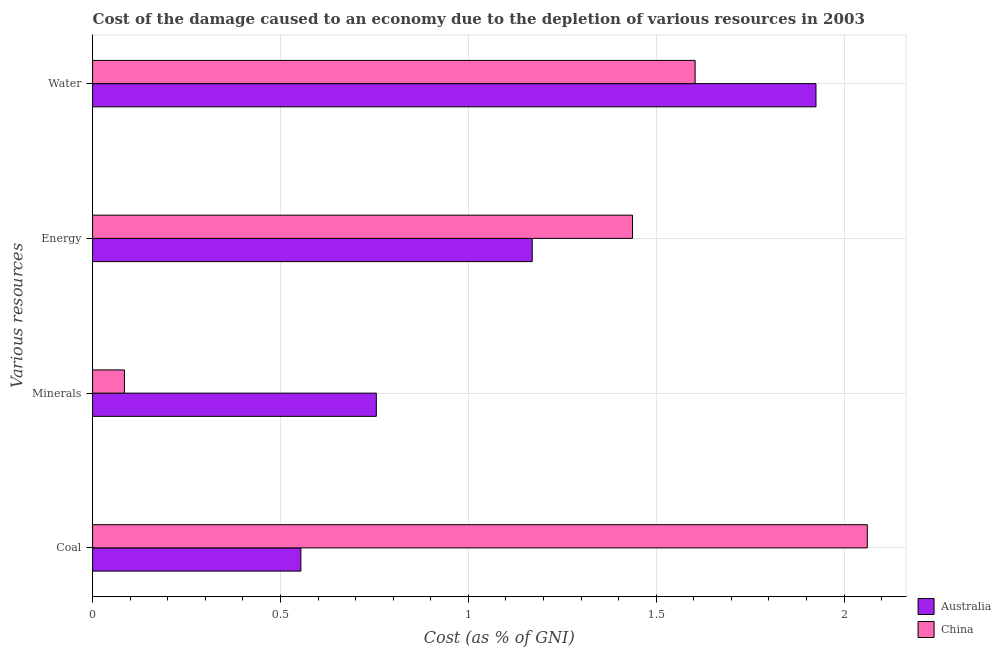How many groups of bars are there?
Provide a succinct answer. 4. Are the number of bars per tick equal to the number of legend labels?
Offer a terse response. Yes. What is the label of the 4th group of bars from the top?
Your response must be concise. Coal. What is the cost of damage due to depletion of coal in Australia?
Provide a succinct answer. 0.55. Across all countries, what is the maximum cost of damage due to depletion of coal?
Make the answer very short. 2.06. Across all countries, what is the minimum cost of damage due to depletion of water?
Your response must be concise. 1.6. In which country was the cost of damage due to depletion of energy minimum?
Your response must be concise. Australia. What is the total cost of damage due to depletion of coal in the graph?
Your answer should be very brief. 2.62. What is the difference between the cost of damage due to depletion of energy in Australia and that in China?
Provide a succinct answer. -0.27. What is the difference between the cost of damage due to depletion of water in China and the cost of damage due to depletion of minerals in Australia?
Provide a succinct answer. 0.85. What is the average cost of damage due to depletion of minerals per country?
Provide a succinct answer. 0.42. What is the difference between the cost of damage due to depletion of coal and cost of damage due to depletion of water in Australia?
Your answer should be very brief. -1.37. What is the ratio of the cost of damage due to depletion of minerals in China to that in Australia?
Your answer should be very brief. 0.11. Is the cost of damage due to depletion of energy in Australia less than that in China?
Provide a short and direct response. Yes. What is the difference between the highest and the second highest cost of damage due to depletion of minerals?
Offer a very short reply. 0.67. What is the difference between the highest and the lowest cost of damage due to depletion of energy?
Your response must be concise. 0.27. Are all the bars in the graph horizontal?
Your answer should be compact. Yes. How many countries are there in the graph?
Provide a short and direct response. 2. Are the values on the major ticks of X-axis written in scientific E-notation?
Your response must be concise. No. Does the graph contain any zero values?
Your answer should be very brief. No. Does the graph contain grids?
Provide a short and direct response. Yes. Where does the legend appear in the graph?
Your response must be concise. Bottom right. How are the legend labels stacked?
Your response must be concise. Vertical. What is the title of the graph?
Offer a terse response. Cost of the damage caused to an economy due to the depletion of various resources in 2003 . Does "Morocco" appear as one of the legend labels in the graph?
Provide a succinct answer. No. What is the label or title of the X-axis?
Offer a terse response. Cost (as % of GNI). What is the label or title of the Y-axis?
Provide a succinct answer. Various resources. What is the Cost (as % of GNI) in Australia in Coal?
Your response must be concise. 0.55. What is the Cost (as % of GNI) in China in Coal?
Your answer should be very brief. 2.06. What is the Cost (as % of GNI) in Australia in Minerals?
Ensure brevity in your answer.  0.76. What is the Cost (as % of GNI) in China in Minerals?
Make the answer very short. 0.08. What is the Cost (as % of GNI) in Australia in Energy?
Give a very brief answer. 1.17. What is the Cost (as % of GNI) in China in Energy?
Make the answer very short. 1.44. What is the Cost (as % of GNI) in Australia in Water?
Your answer should be very brief. 1.93. What is the Cost (as % of GNI) in China in Water?
Your answer should be compact. 1.6. Across all Various resources, what is the maximum Cost (as % of GNI) in Australia?
Make the answer very short. 1.93. Across all Various resources, what is the maximum Cost (as % of GNI) of China?
Provide a succinct answer. 2.06. Across all Various resources, what is the minimum Cost (as % of GNI) in Australia?
Give a very brief answer. 0.55. Across all Various resources, what is the minimum Cost (as % of GNI) of China?
Offer a terse response. 0.08. What is the total Cost (as % of GNI) in Australia in the graph?
Provide a succinct answer. 4.4. What is the total Cost (as % of GNI) of China in the graph?
Provide a succinct answer. 5.19. What is the difference between the Cost (as % of GNI) in Australia in Coal and that in Minerals?
Your answer should be compact. -0.2. What is the difference between the Cost (as % of GNI) in China in Coal and that in Minerals?
Your answer should be compact. 1.98. What is the difference between the Cost (as % of GNI) of Australia in Coal and that in Energy?
Keep it short and to the point. -0.62. What is the difference between the Cost (as % of GNI) of China in Coal and that in Energy?
Your answer should be compact. 0.62. What is the difference between the Cost (as % of GNI) of Australia in Coal and that in Water?
Your answer should be very brief. -1.37. What is the difference between the Cost (as % of GNI) in China in Coal and that in Water?
Ensure brevity in your answer.  0.46. What is the difference between the Cost (as % of GNI) in Australia in Minerals and that in Energy?
Make the answer very short. -0.41. What is the difference between the Cost (as % of GNI) of China in Minerals and that in Energy?
Make the answer very short. -1.35. What is the difference between the Cost (as % of GNI) of Australia in Minerals and that in Water?
Keep it short and to the point. -1.17. What is the difference between the Cost (as % of GNI) in China in Minerals and that in Water?
Offer a very short reply. -1.52. What is the difference between the Cost (as % of GNI) of Australia in Energy and that in Water?
Make the answer very short. -0.76. What is the difference between the Cost (as % of GNI) in China in Energy and that in Water?
Provide a succinct answer. -0.17. What is the difference between the Cost (as % of GNI) of Australia in Coal and the Cost (as % of GNI) of China in Minerals?
Give a very brief answer. 0.47. What is the difference between the Cost (as % of GNI) in Australia in Coal and the Cost (as % of GNI) in China in Energy?
Your response must be concise. -0.88. What is the difference between the Cost (as % of GNI) in Australia in Coal and the Cost (as % of GNI) in China in Water?
Keep it short and to the point. -1.05. What is the difference between the Cost (as % of GNI) in Australia in Minerals and the Cost (as % of GNI) in China in Energy?
Your response must be concise. -0.68. What is the difference between the Cost (as % of GNI) of Australia in Minerals and the Cost (as % of GNI) of China in Water?
Your answer should be very brief. -0.85. What is the difference between the Cost (as % of GNI) of Australia in Energy and the Cost (as % of GNI) of China in Water?
Offer a terse response. -0.43. What is the average Cost (as % of GNI) in Australia per Various resources?
Your answer should be compact. 1.1. What is the average Cost (as % of GNI) of China per Various resources?
Ensure brevity in your answer.  1.3. What is the difference between the Cost (as % of GNI) of Australia and Cost (as % of GNI) of China in Coal?
Make the answer very short. -1.51. What is the difference between the Cost (as % of GNI) in Australia and Cost (as % of GNI) in China in Minerals?
Provide a succinct answer. 0.67. What is the difference between the Cost (as % of GNI) in Australia and Cost (as % of GNI) in China in Energy?
Offer a terse response. -0.27. What is the difference between the Cost (as % of GNI) in Australia and Cost (as % of GNI) in China in Water?
Keep it short and to the point. 0.32. What is the ratio of the Cost (as % of GNI) in Australia in Coal to that in Minerals?
Ensure brevity in your answer.  0.73. What is the ratio of the Cost (as % of GNI) in China in Coal to that in Minerals?
Provide a short and direct response. 24.31. What is the ratio of the Cost (as % of GNI) of Australia in Coal to that in Energy?
Offer a terse response. 0.47. What is the ratio of the Cost (as % of GNI) of China in Coal to that in Energy?
Make the answer very short. 1.43. What is the ratio of the Cost (as % of GNI) in Australia in Coal to that in Water?
Keep it short and to the point. 0.29. What is the ratio of the Cost (as % of GNI) in China in Coal to that in Water?
Your response must be concise. 1.29. What is the ratio of the Cost (as % of GNI) in Australia in Minerals to that in Energy?
Make the answer very short. 0.65. What is the ratio of the Cost (as % of GNI) of China in Minerals to that in Energy?
Your response must be concise. 0.06. What is the ratio of the Cost (as % of GNI) of Australia in Minerals to that in Water?
Your answer should be very brief. 0.39. What is the ratio of the Cost (as % of GNI) in China in Minerals to that in Water?
Offer a terse response. 0.05. What is the ratio of the Cost (as % of GNI) in Australia in Energy to that in Water?
Your answer should be compact. 0.61. What is the ratio of the Cost (as % of GNI) in China in Energy to that in Water?
Offer a terse response. 0.9. What is the difference between the highest and the second highest Cost (as % of GNI) of Australia?
Provide a succinct answer. 0.76. What is the difference between the highest and the second highest Cost (as % of GNI) in China?
Your response must be concise. 0.46. What is the difference between the highest and the lowest Cost (as % of GNI) of Australia?
Provide a short and direct response. 1.37. What is the difference between the highest and the lowest Cost (as % of GNI) in China?
Offer a terse response. 1.98. 